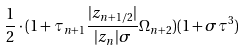Convert formula to latex. <formula><loc_0><loc_0><loc_500><loc_500>\frac { 1 } { 2 } \cdot ( 1 + \tau _ { n + 1 } \frac { | z _ { n + 1 / 2 } | } { | z _ { n } | \sigma } \Omega _ { n + 2 } ) ( 1 + \sigma \tau ^ { 3 } )</formula> 